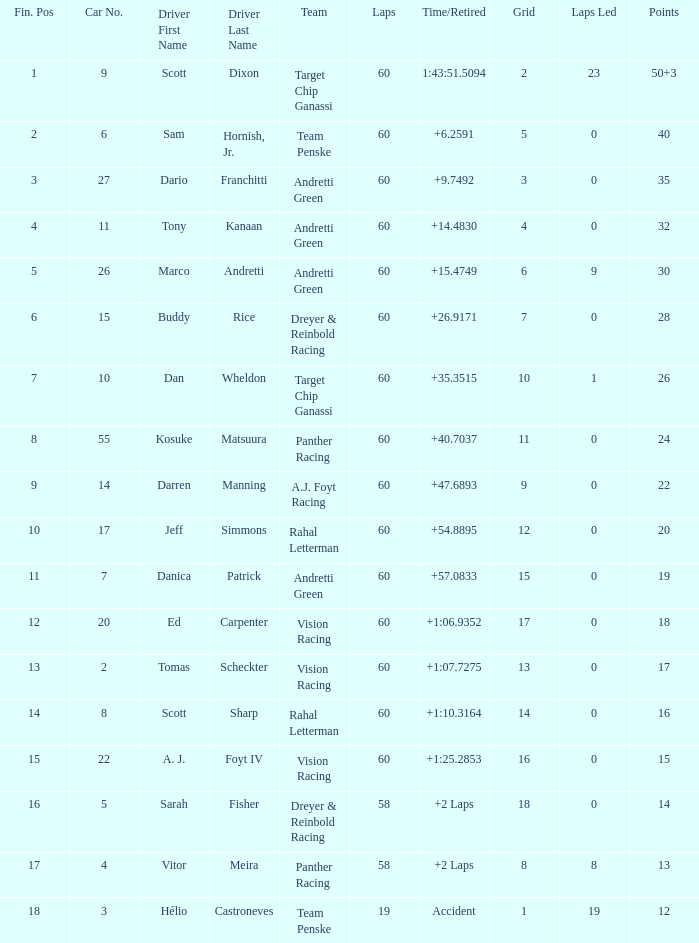Name the team for scott dixon Target Chip Ganassi. 